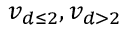Convert formula to latex. <formula><loc_0><loc_0><loc_500><loc_500>v _ { d \leq 2 } , v _ { d > 2 }</formula> 